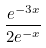<formula> <loc_0><loc_0><loc_500><loc_500>\frac { e ^ { - 3 x } } { 2 e ^ { - x } }</formula> 